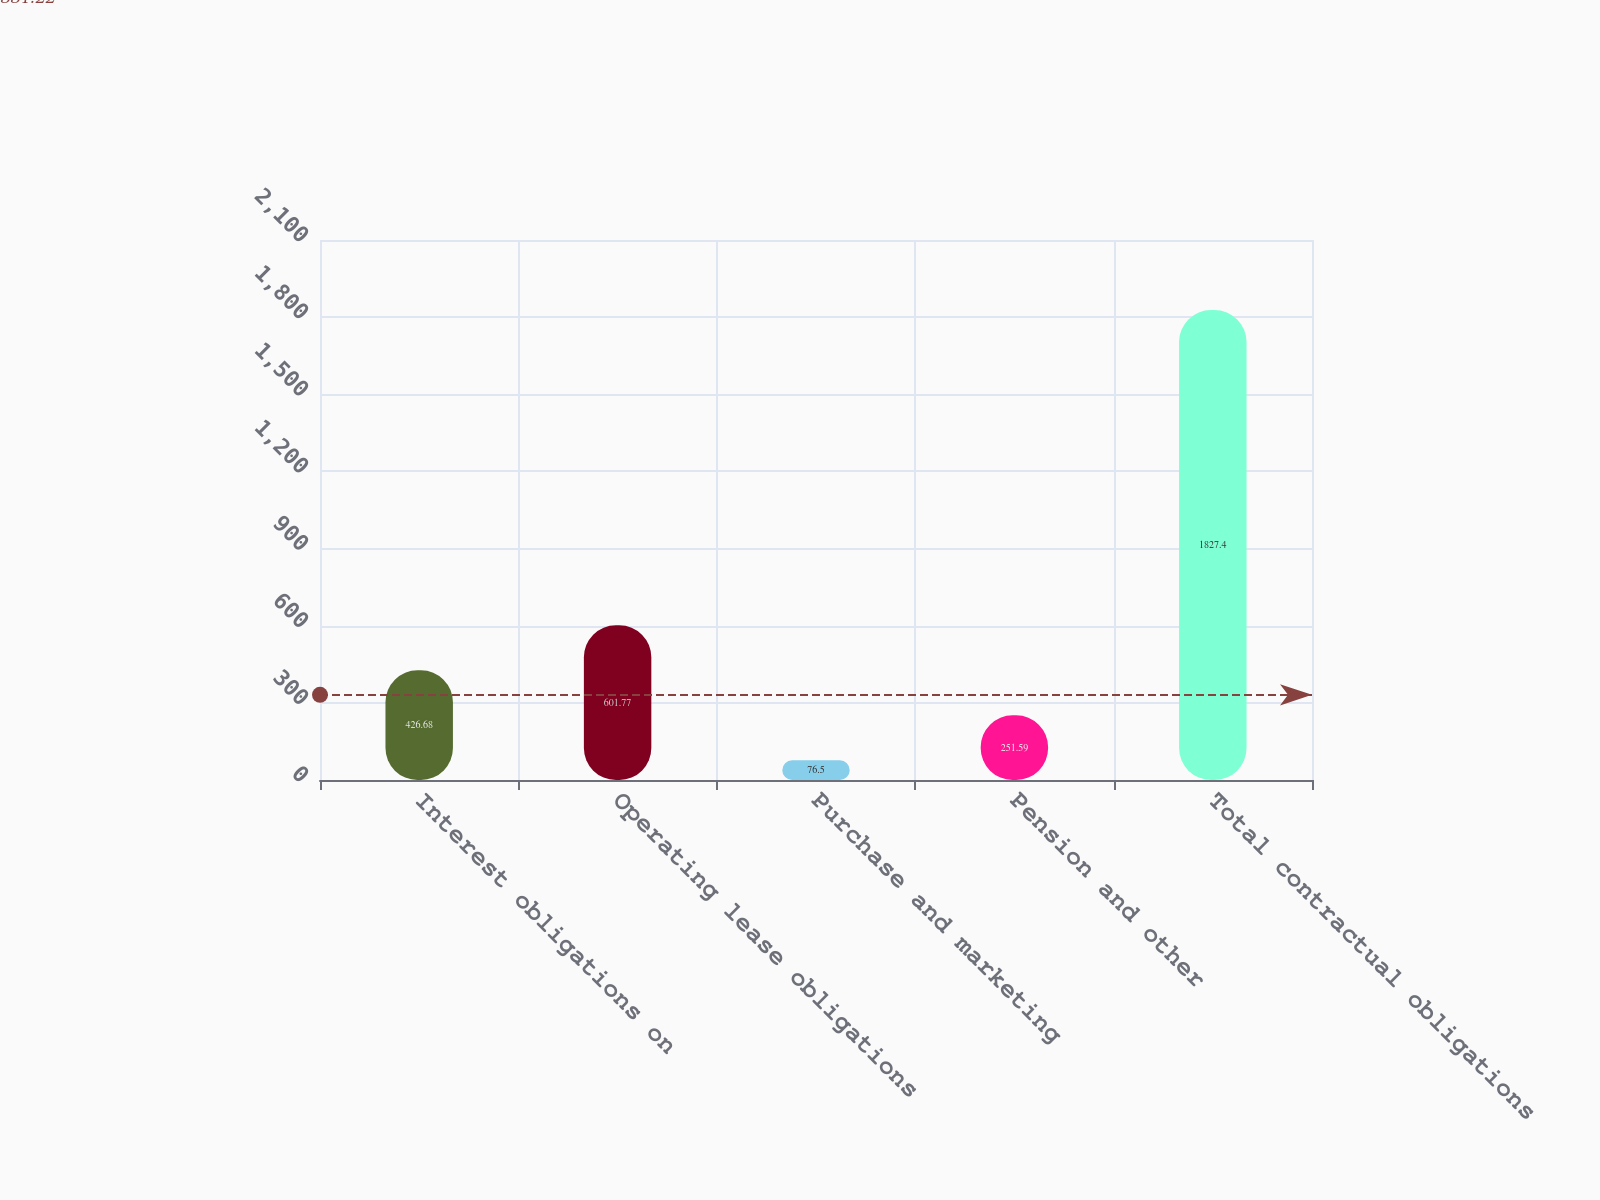Convert chart to OTSL. <chart><loc_0><loc_0><loc_500><loc_500><bar_chart><fcel>Interest obligations on<fcel>Operating lease obligations<fcel>Purchase and marketing<fcel>Pension and other<fcel>Total contractual obligations<nl><fcel>426.68<fcel>601.77<fcel>76.5<fcel>251.59<fcel>1827.4<nl></chart> 